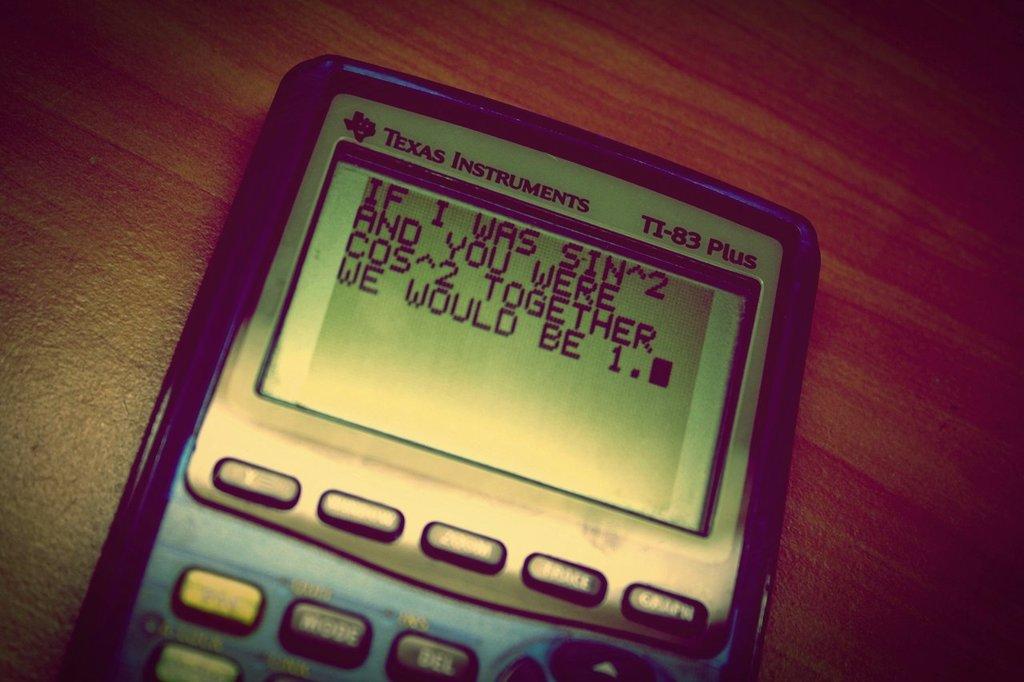What is the number of the calculator?
Your response must be concise. 83. What brand is the calculator?
Keep it short and to the point. Texas instruments. 